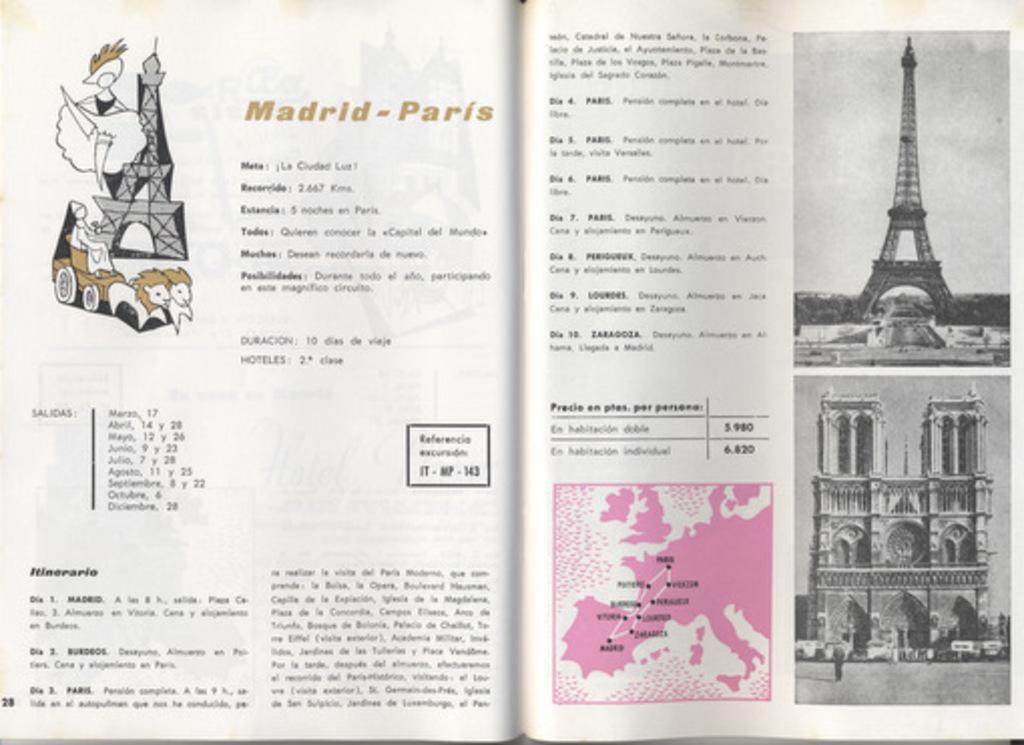Describe this image in one or two sentences. In this image there is an open book with some images and text on it. 